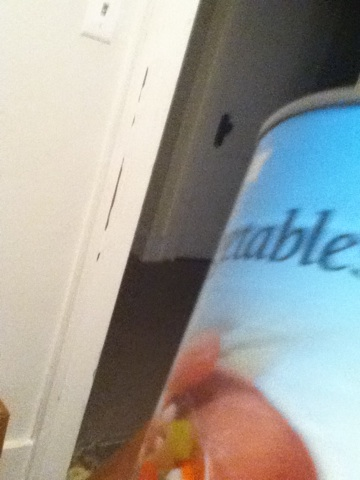what is this can This is a can of mixed vegetables, typically containing a variety of vegetables such as carrots, peas, potatoes, and beans. 